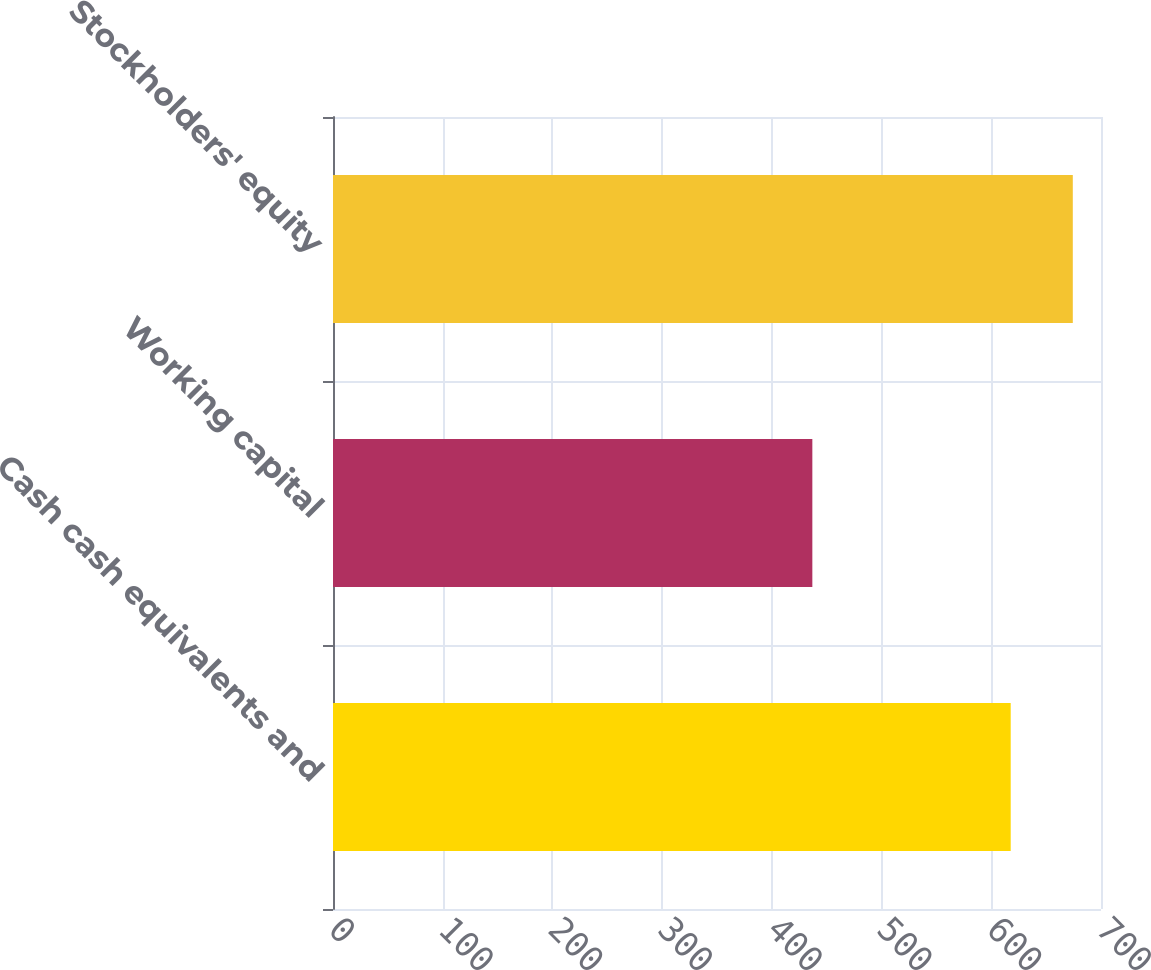Convert chart. <chart><loc_0><loc_0><loc_500><loc_500><bar_chart><fcel>Cash cash equivalents and<fcel>Working capital<fcel>Stockholders' equity<nl><fcel>617.7<fcel>436.9<fcel>674.3<nl></chart> 